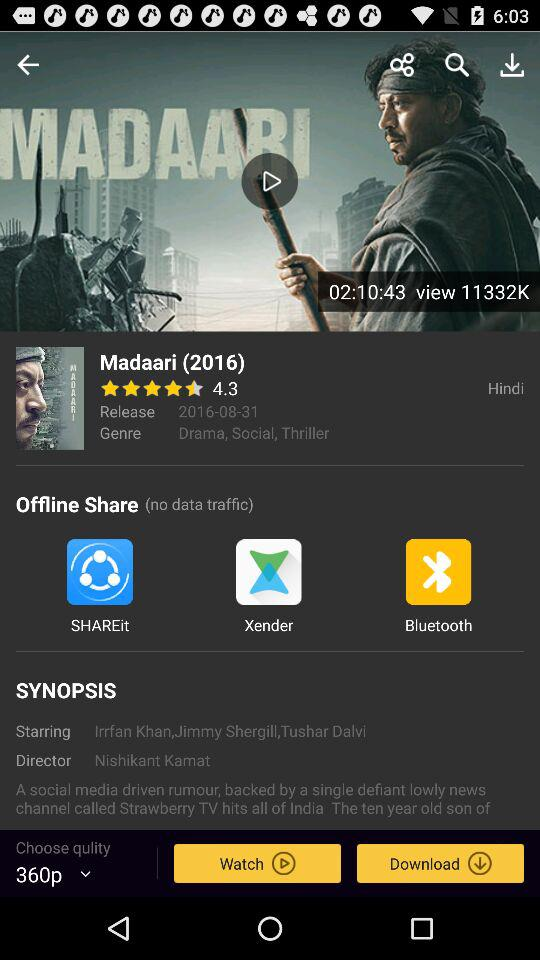Through which applications can the movie be shared offline? The applications are "SHAREit", "Xender" and "Bluetooth". 